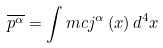<formula> <loc_0><loc_0><loc_500><loc_500>\overline { p ^ { \alpha } } = \int m c j ^ { \alpha } \left ( x \right ) d ^ { 4 } x</formula> 